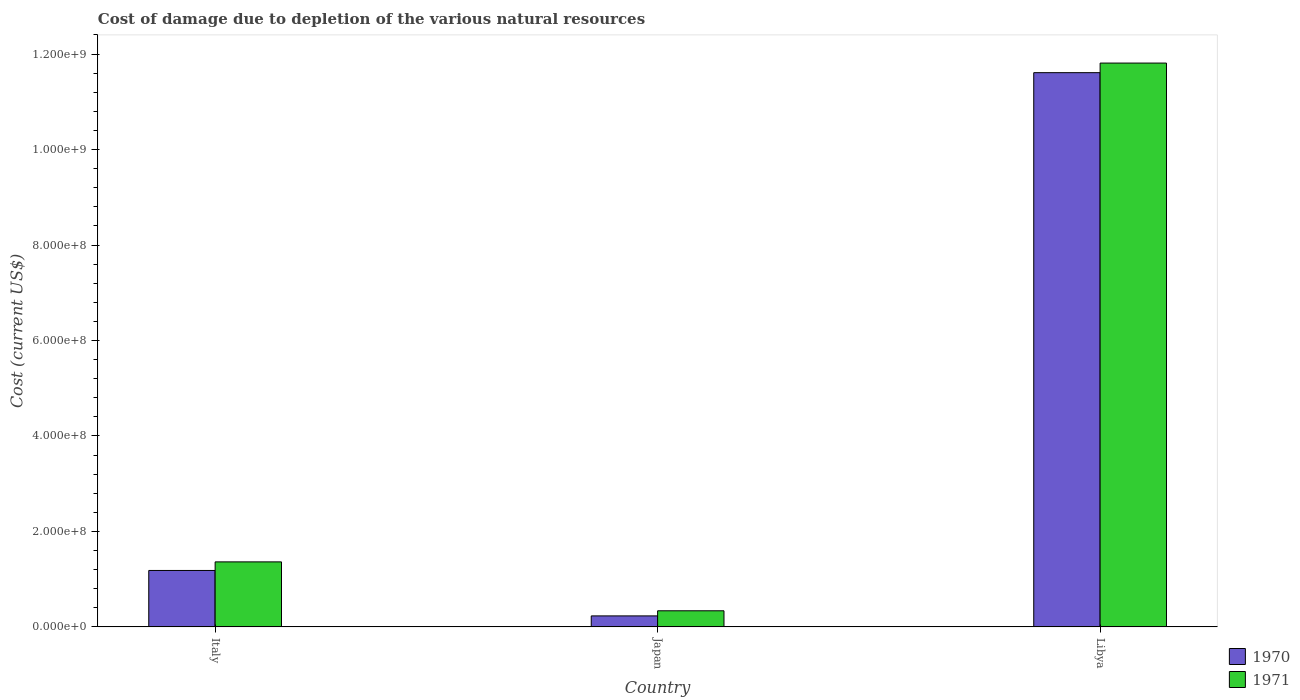How many bars are there on the 1st tick from the left?
Provide a short and direct response. 2. How many bars are there on the 3rd tick from the right?
Make the answer very short. 2. What is the cost of damage caused due to the depletion of various natural resources in 1970 in Libya?
Ensure brevity in your answer.  1.16e+09. Across all countries, what is the maximum cost of damage caused due to the depletion of various natural resources in 1971?
Keep it short and to the point. 1.18e+09. Across all countries, what is the minimum cost of damage caused due to the depletion of various natural resources in 1971?
Give a very brief answer. 3.37e+07. In which country was the cost of damage caused due to the depletion of various natural resources in 1970 maximum?
Your response must be concise. Libya. What is the total cost of damage caused due to the depletion of various natural resources in 1971 in the graph?
Provide a short and direct response. 1.35e+09. What is the difference between the cost of damage caused due to the depletion of various natural resources in 1970 in Japan and that in Libya?
Your answer should be very brief. -1.14e+09. What is the difference between the cost of damage caused due to the depletion of various natural resources in 1971 in Libya and the cost of damage caused due to the depletion of various natural resources in 1970 in Italy?
Offer a terse response. 1.06e+09. What is the average cost of damage caused due to the depletion of various natural resources in 1970 per country?
Your response must be concise. 4.34e+08. What is the difference between the cost of damage caused due to the depletion of various natural resources of/in 1971 and cost of damage caused due to the depletion of various natural resources of/in 1970 in Japan?
Provide a succinct answer. 1.07e+07. What is the ratio of the cost of damage caused due to the depletion of various natural resources in 1971 in Italy to that in Libya?
Ensure brevity in your answer.  0.12. Is the cost of damage caused due to the depletion of various natural resources in 1970 in Italy less than that in Libya?
Provide a succinct answer. Yes. Is the difference between the cost of damage caused due to the depletion of various natural resources in 1971 in Italy and Libya greater than the difference between the cost of damage caused due to the depletion of various natural resources in 1970 in Italy and Libya?
Your answer should be very brief. No. What is the difference between the highest and the second highest cost of damage caused due to the depletion of various natural resources in 1971?
Ensure brevity in your answer.  1.02e+08. What is the difference between the highest and the lowest cost of damage caused due to the depletion of various natural resources in 1970?
Provide a succinct answer. 1.14e+09. In how many countries, is the cost of damage caused due to the depletion of various natural resources in 1971 greater than the average cost of damage caused due to the depletion of various natural resources in 1971 taken over all countries?
Ensure brevity in your answer.  1. Is the sum of the cost of damage caused due to the depletion of various natural resources in 1971 in Italy and Libya greater than the maximum cost of damage caused due to the depletion of various natural resources in 1970 across all countries?
Keep it short and to the point. Yes. How many bars are there?
Make the answer very short. 6. Are all the bars in the graph horizontal?
Your answer should be very brief. No. Does the graph contain any zero values?
Offer a terse response. No. Does the graph contain grids?
Your response must be concise. No. How many legend labels are there?
Keep it short and to the point. 2. What is the title of the graph?
Give a very brief answer. Cost of damage due to depletion of the various natural resources. What is the label or title of the X-axis?
Make the answer very short. Country. What is the label or title of the Y-axis?
Provide a succinct answer. Cost (current US$). What is the Cost (current US$) of 1970 in Italy?
Offer a terse response. 1.18e+08. What is the Cost (current US$) in 1971 in Italy?
Offer a terse response. 1.36e+08. What is the Cost (current US$) in 1970 in Japan?
Make the answer very short. 2.30e+07. What is the Cost (current US$) of 1971 in Japan?
Your response must be concise. 3.37e+07. What is the Cost (current US$) of 1970 in Libya?
Your response must be concise. 1.16e+09. What is the Cost (current US$) in 1971 in Libya?
Keep it short and to the point. 1.18e+09. Across all countries, what is the maximum Cost (current US$) in 1970?
Your response must be concise. 1.16e+09. Across all countries, what is the maximum Cost (current US$) of 1971?
Provide a short and direct response. 1.18e+09. Across all countries, what is the minimum Cost (current US$) of 1970?
Ensure brevity in your answer.  2.30e+07. Across all countries, what is the minimum Cost (current US$) of 1971?
Provide a succinct answer. 3.37e+07. What is the total Cost (current US$) in 1970 in the graph?
Offer a terse response. 1.30e+09. What is the total Cost (current US$) in 1971 in the graph?
Give a very brief answer. 1.35e+09. What is the difference between the Cost (current US$) of 1970 in Italy and that in Japan?
Provide a short and direct response. 9.52e+07. What is the difference between the Cost (current US$) of 1971 in Italy and that in Japan?
Make the answer very short. 1.02e+08. What is the difference between the Cost (current US$) of 1970 in Italy and that in Libya?
Your answer should be very brief. -1.04e+09. What is the difference between the Cost (current US$) of 1971 in Italy and that in Libya?
Your answer should be very brief. -1.05e+09. What is the difference between the Cost (current US$) in 1970 in Japan and that in Libya?
Offer a terse response. -1.14e+09. What is the difference between the Cost (current US$) of 1971 in Japan and that in Libya?
Offer a terse response. -1.15e+09. What is the difference between the Cost (current US$) in 1970 in Italy and the Cost (current US$) in 1971 in Japan?
Your response must be concise. 8.45e+07. What is the difference between the Cost (current US$) of 1970 in Italy and the Cost (current US$) of 1971 in Libya?
Your response must be concise. -1.06e+09. What is the difference between the Cost (current US$) in 1970 in Japan and the Cost (current US$) in 1971 in Libya?
Your answer should be compact. -1.16e+09. What is the average Cost (current US$) in 1970 per country?
Keep it short and to the point. 4.34e+08. What is the average Cost (current US$) in 1971 per country?
Make the answer very short. 4.50e+08. What is the difference between the Cost (current US$) in 1970 and Cost (current US$) in 1971 in Italy?
Your response must be concise. -1.80e+07. What is the difference between the Cost (current US$) of 1970 and Cost (current US$) of 1971 in Japan?
Your answer should be very brief. -1.07e+07. What is the difference between the Cost (current US$) in 1970 and Cost (current US$) in 1971 in Libya?
Make the answer very short. -2.01e+07. What is the ratio of the Cost (current US$) in 1970 in Italy to that in Japan?
Provide a short and direct response. 5.14. What is the ratio of the Cost (current US$) of 1971 in Italy to that in Japan?
Provide a succinct answer. 4.04. What is the ratio of the Cost (current US$) in 1970 in Italy to that in Libya?
Your answer should be very brief. 0.1. What is the ratio of the Cost (current US$) of 1971 in Italy to that in Libya?
Your response must be concise. 0.12. What is the ratio of the Cost (current US$) of 1970 in Japan to that in Libya?
Give a very brief answer. 0.02. What is the ratio of the Cost (current US$) of 1971 in Japan to that in Libya?
Provide a succinct answer. 0.03. What is the difference between the highest and the second highest Cost (current US$) in 1970?
Give a very brief answer. 1.04e+09. What is the difference between the highest and the second highest Cost (current US$) of 1971?
Offer a very short reply. 1.05e+09. What is the difference between the highest and the lowest Cost (current US$) of 1970?
Your response must be concise. 1.14e+09. What is the difference between the highest and the lowest Cost (current US$) of 1971?
Your response must be concise. 1.15e+09. 